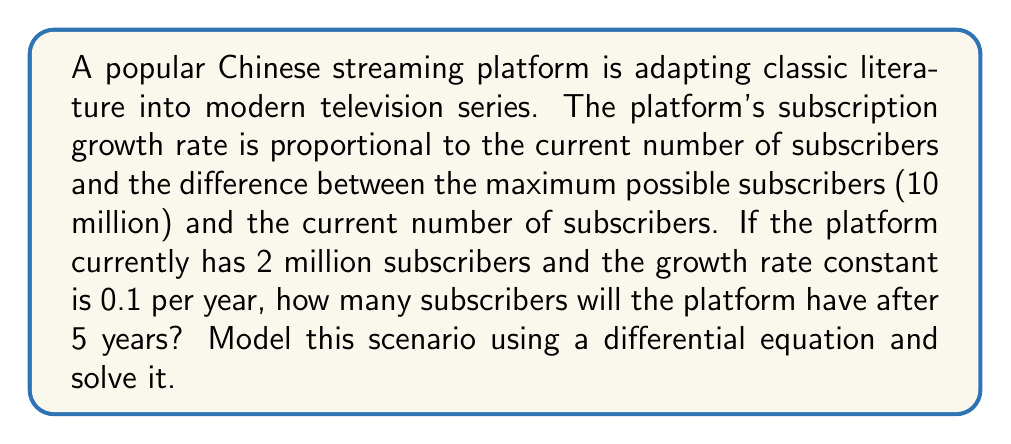Give your solution to this math problem. Let's approach this step-by-step:

1) Let $S(t)$ be the number of subscribers at time $t$ in years. The given information can be modeled using the logistic differential equation:

   $$\frac{dS}{dt} = kS(M-S)$$

   where $k$ is the growth rate constant and $M$ is the maximum number of subscribers.

2) We're given:
   $k = 0.1$
   $M = 10$ million
   $S(0) = 2$ million (initial condition)

3) Substituting these values, our differential equation becomes:

   $$\frac{dS}{dt} = 0.1S(10-S)$$

4) The solution to this logistic equation is:

   $$S(t) = \frac{M}{1 + (\frac{M}{S_0} - 1)e^{-kMt}}$$

   where $S_0$ is the initial number of subscribers.

5) Substituting our values:

   $$S(t) = \frac{10}{1 + (\frac{10}{2} - 1)e^{-0.1 \cdot 10 \cdot t}}$$

6) Simplify:

   $$S(t) = \frac{10}{1 + 4e^{-t}}$$

7) We want to find $S(5)$, so let's substitute $t=5$:

   $$S(5) = \frac{10}{1 + 4e^{-5}}$$

8) Calculate:
   $$S(5) \approx 9.3329$$ million subscribers
Answer: 9.3329 million subscribers 